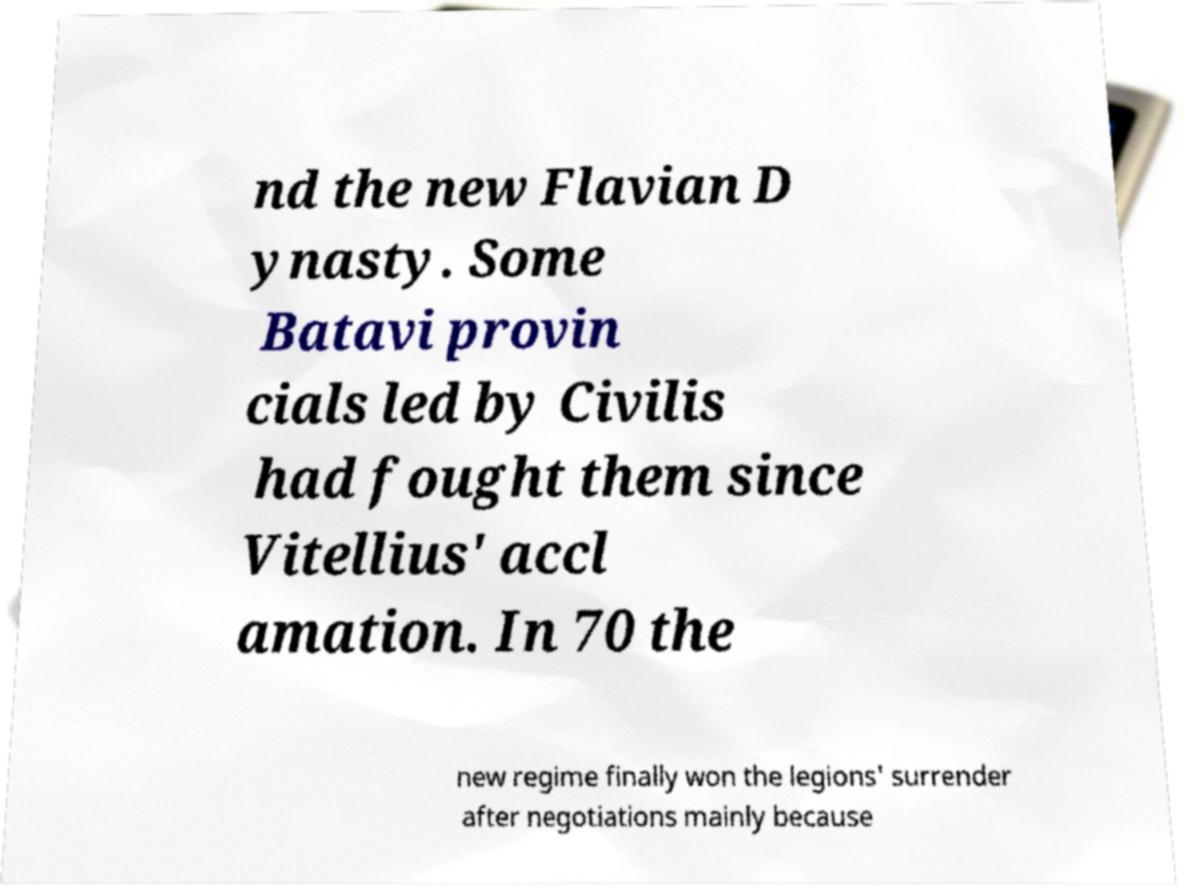Can you read and provide the text displayed in the image?This photo seems to have some interesting text. Can you extract and type it out for me? nd the new Flavian D ynasty. Some Batavi provin cials led by Civilis had fought them since Vitellius' accl amation. In 70 the new regime finally won the legions' surrender after negotiations mainly because 